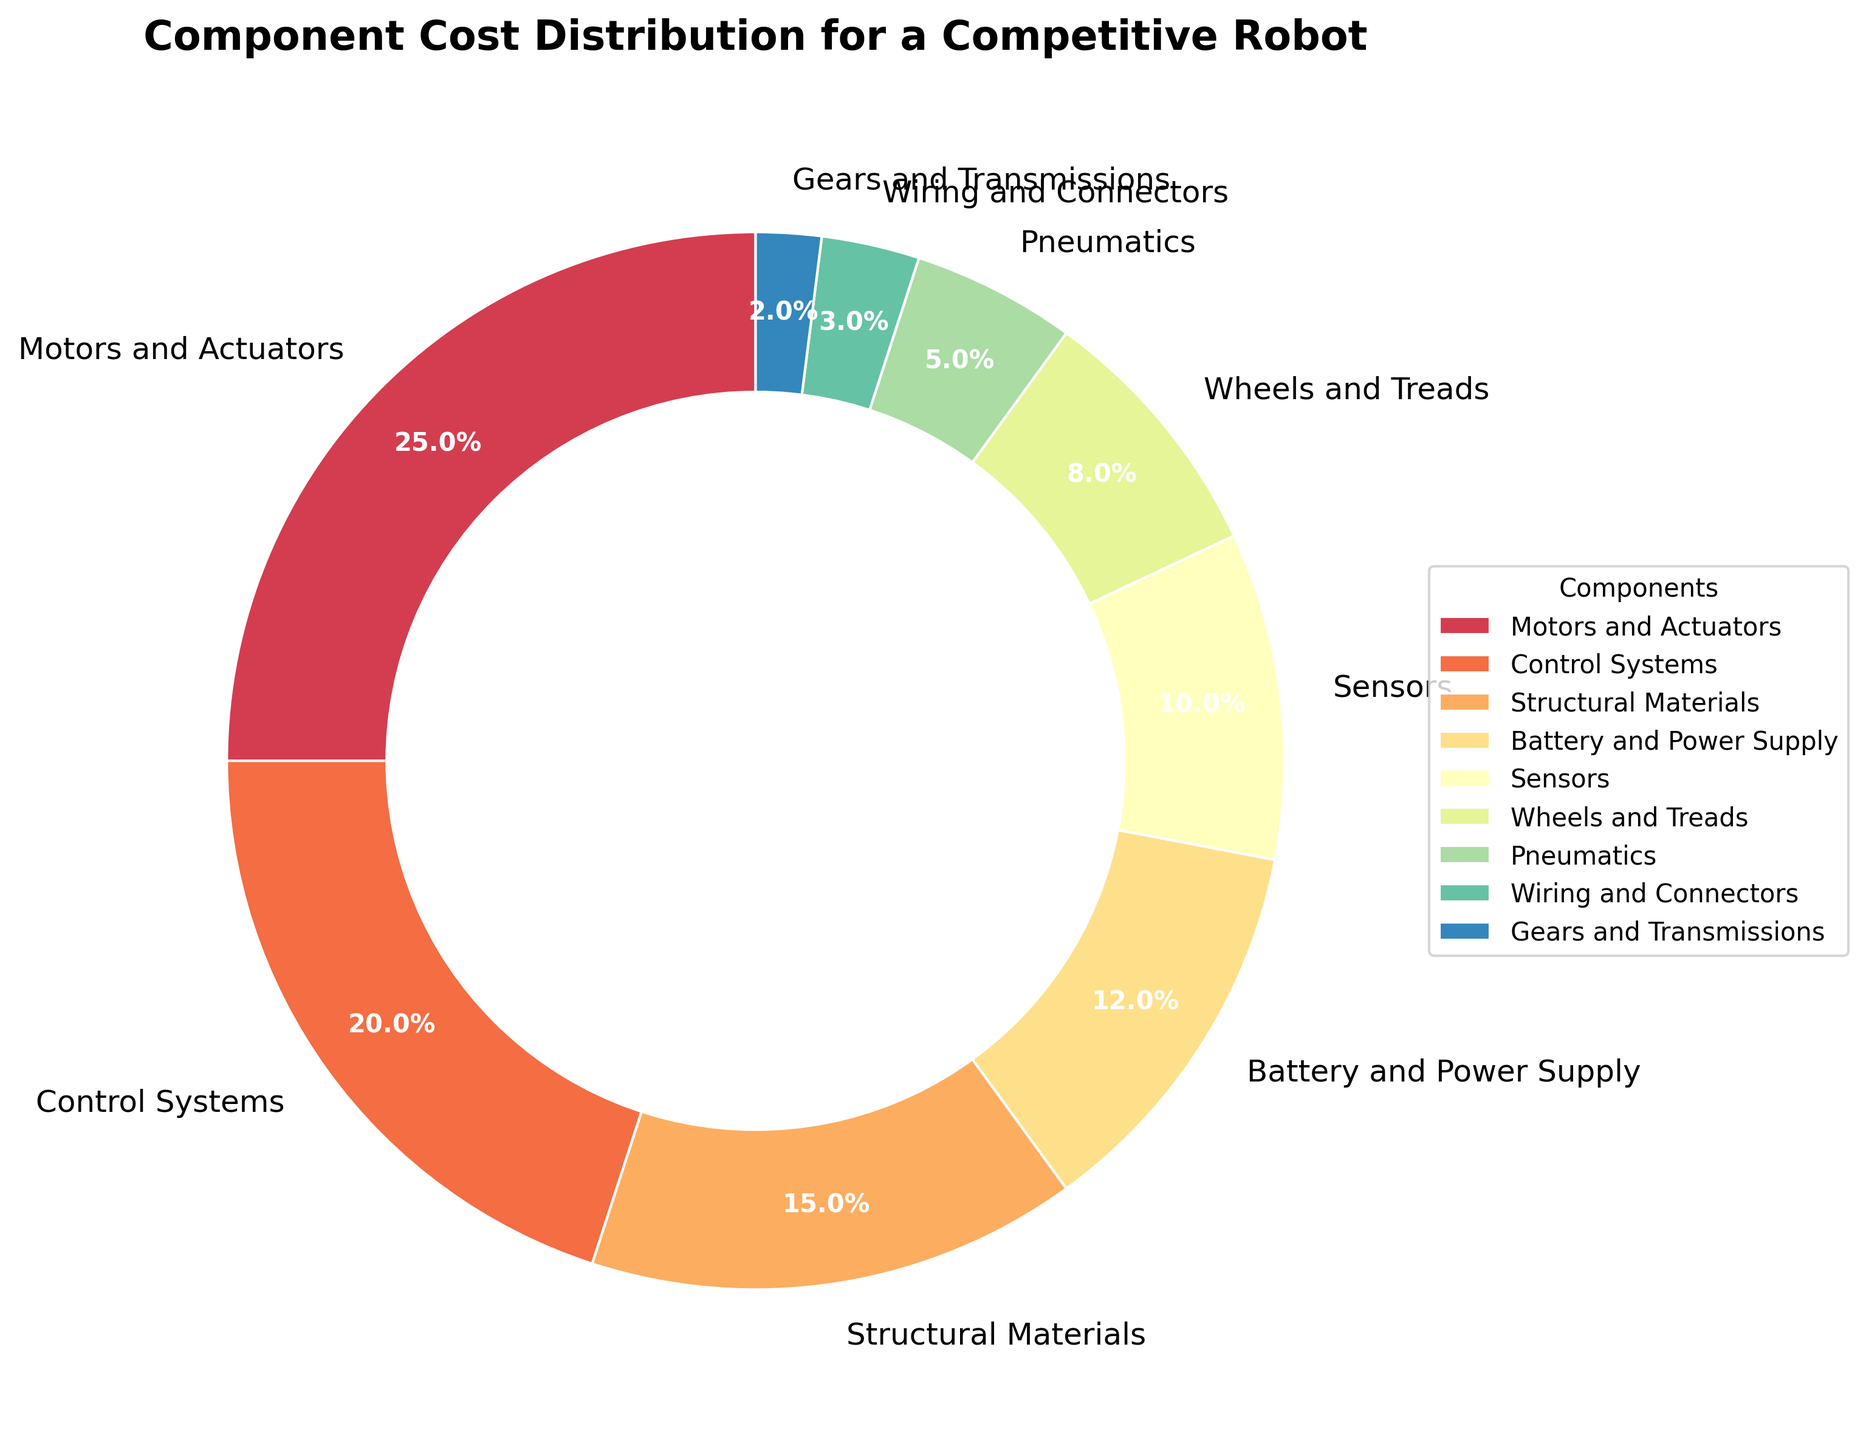What are the two most expensive components in the robot as per the chart? The chart shows that the "Motors and Actuators" category has the largest portion, followed by "Control Systems". These two categories have the highest percentage of costs.
Answer: Motors and Actuators, Control Systems Which components contribute exactly 20% of the costs? By looking at the chart, the component labeled "Control Systems" is the one with 20% cost.
Answer: Control Systems What is the total cost percentage of the three components with the lowest expenses? Add the percentages of "Gears and Transmissions" (2%), "Wiring and Connectors" (3%), and "Pneumatics" (5%). The sum is 2 + 3 + 5 = 10%.
Answer: 10% Is the cost of Sensors higher or lower than the cost of Structural Materials? From the chart, we can see that the cost for "Structural Materials" is 15%, while "Sensors" is 10%. Therefore, Sensors' cost is lower.
Answer: Lower Which component category has less expense, "Battery and Power Supply" or "Wheels and Treads"? From the chart, the "Battery and Power Supply" stands at 12% and "Wheels and Treads" at 8%. Thus, "Wheels and Treads" has less expense.
Answer: Wheels and Treads What is the combined cost percentage of Motors and Actuators, and Control Systems? Adding the percentages of "Motors and Actuators" (25%) and "Control Systems" (20%), we get 25 + 20 = 45%.
Answer: 45% What is the percentage difference between the highest and lowest cost components? The highest cost component is "Motors and Actuators" at 25%, and the lowest is "Gears and Transmissions" at 2%. The difference is 25 - 2 = 23%.
Answer: 23% If the cost of every component was reduced by 3%, which component(s) would then have less than 2% cost? Subtract 3% from each component's cost: "Gears and Transmissions" (2% - 3% = -1%). This component would be negative, so effectively less than 2%.
Answer: Gears and Transmissions Which color is used to represent the component "Battery and Power Supply"? Observing the chart, each component is associated with a unique color. "Battery and Power Supply" appears in a shade of the color palette used.
Answer: (Color based on the color palette, Spectral) How does the visual size of the "Sensors" portion compare to the "Pneumatics"? "Sensors" cover 10% and "Pneumatics" cover 5%. Since 10% is double 5%, "Sensors" will visually be twice the size as "Pneumatics" in the pie chart.
Answer: Twice as big 